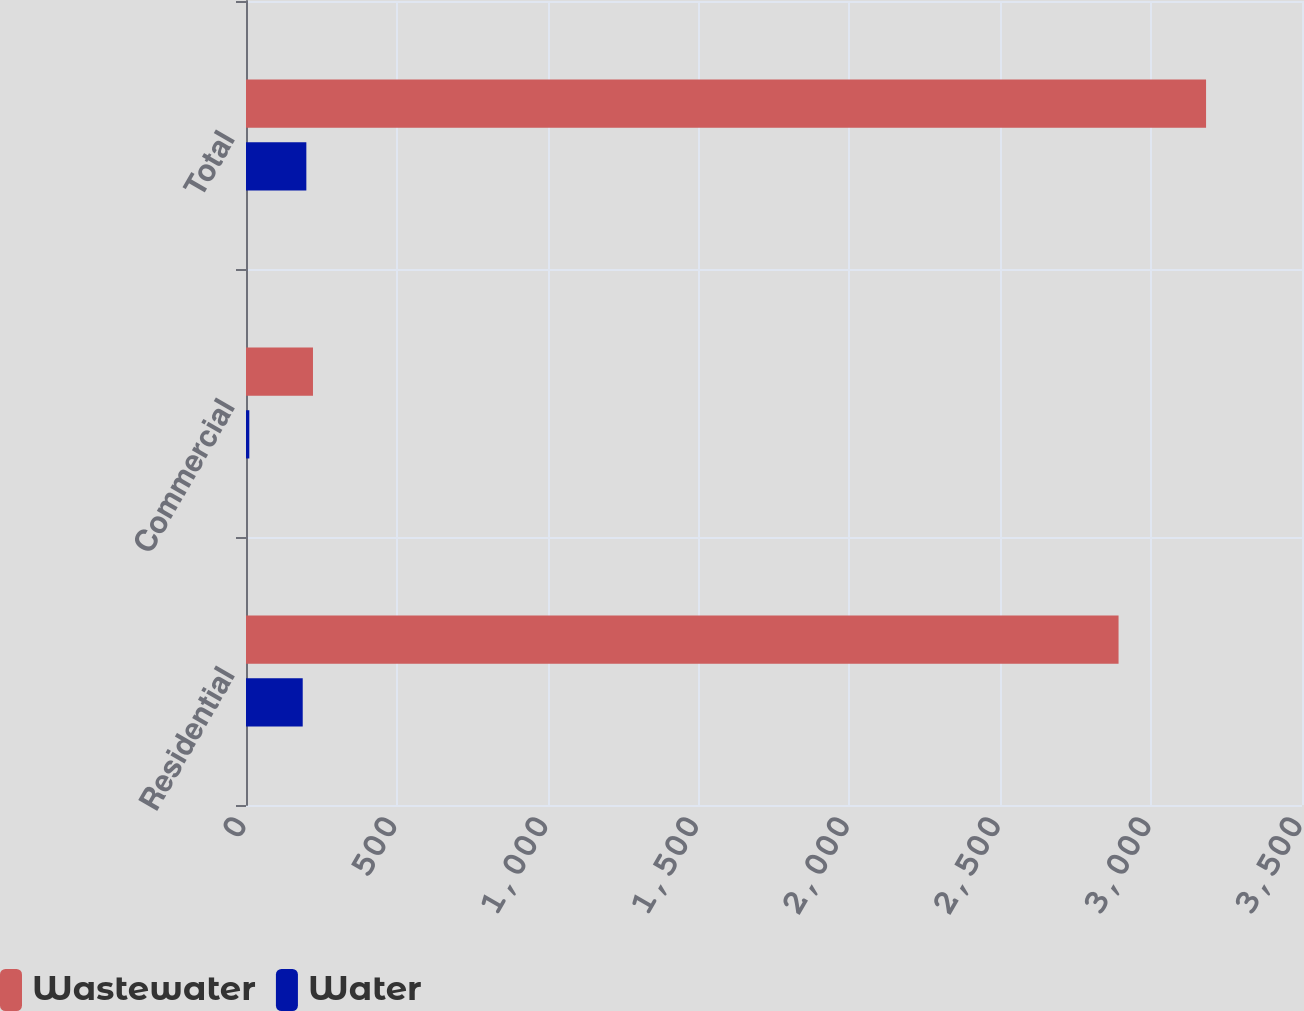Convert chart to OTSL. <chart><loc_0><loc_0><loc_500><loc_500><stacked_bar_chart><ecel><fcel>Residential<fcel>Commercial<fcel>Total<nl><fcel>Wastewater<fcel>2892<fcel>222<fcel>3182<nl><fcel>Water<fcel>188<fcel>11<fcel>200<nl></chart> 